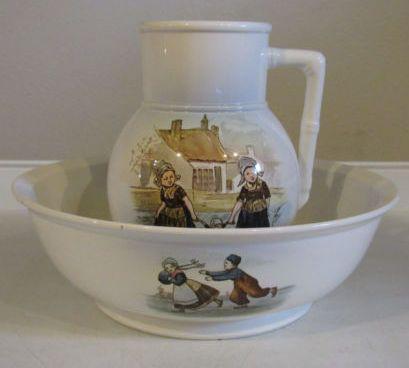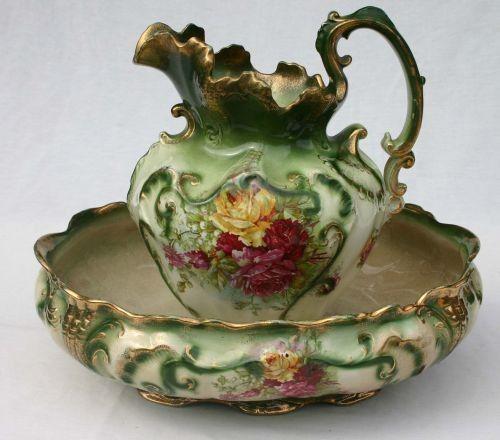The first image is the image on the left, the second image is the image on the right. Evaluate the accuracy of this statement regarding the images: "The spout of every pitcher is facing to the left.". Is it true? Answer yes or no. Yes. The first image is the image on the left, the second image is the image on the right. For the images displayed, is the sentence "Both handles are on the right side." factually correct? Answer yes or no. Yes. 